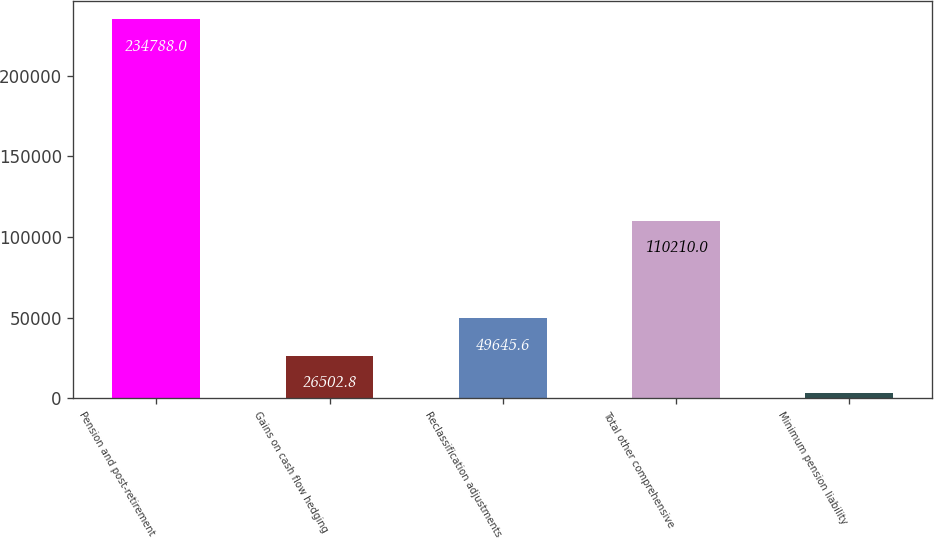Convert chart to OTSL. <chart><loc_0><loc_0><loc_500><loc_500><bar_chart><fcel>Pension and post-retirement<fcel>Gains on cash flow hedging<fcel>Reclassification adjustments<fcel>Total other comprehensive<fcel>Minimum pension liability<nl><fcel>234788<fcel>26502.8<fcel>49645.6<fcel>110210<fcel>3360<nl></chart> 